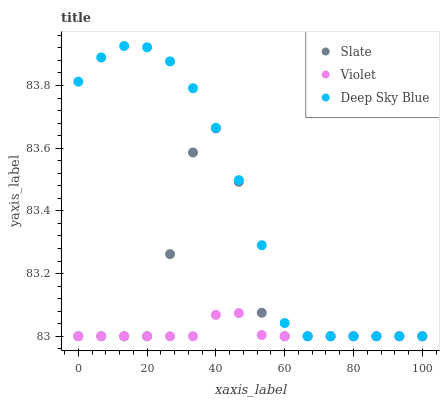Does Violet have the minimum area under the curve?
Answer yes or no. Yes. Does Deep Sky Blue have the maximum area under the curve?
Answer yes or no. Yes. Does Deep Sky Blue have the minimum area under the curve?
Answer yes or no. No. Does Violet have the maximum area under the curve?
Answer yes or no. No. Is Violet the smoothest?
Answer yes or no. Yes. Is Slate the roughest?
Answer yes or no. Yes. Is Deep Sky Blue the smoothest?
Answer yes or no. No. Is Deep Sky Blue the roughest?
Answer yes or no. No. Does Slate have the lowest value?
Answer yes or no. Yes. Does Deep Sky Blue have the highest value?
Answer yes or no. Yes. Does Violet have the highest value?
Answer yes or no. No. Does Deep Sky Blue intersect Slate?
Answer yes or no. Yes. Is Deep Sky Blue less than Slate?
Answer yes or no. No. Is Deep Sky Blue greater than Slate?
Answer yes or no. No. 